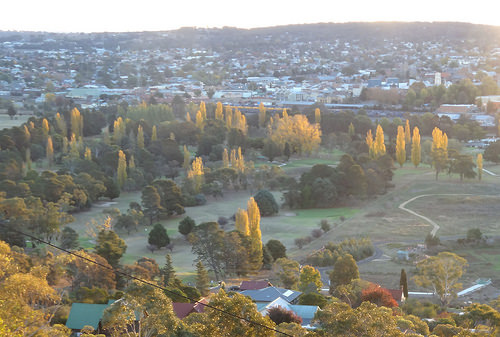<image>
Can you confirm if the tree is to the right of the tree? No. The tree is not to the right of the tree. The horizontal positioning shows a different relationship. 